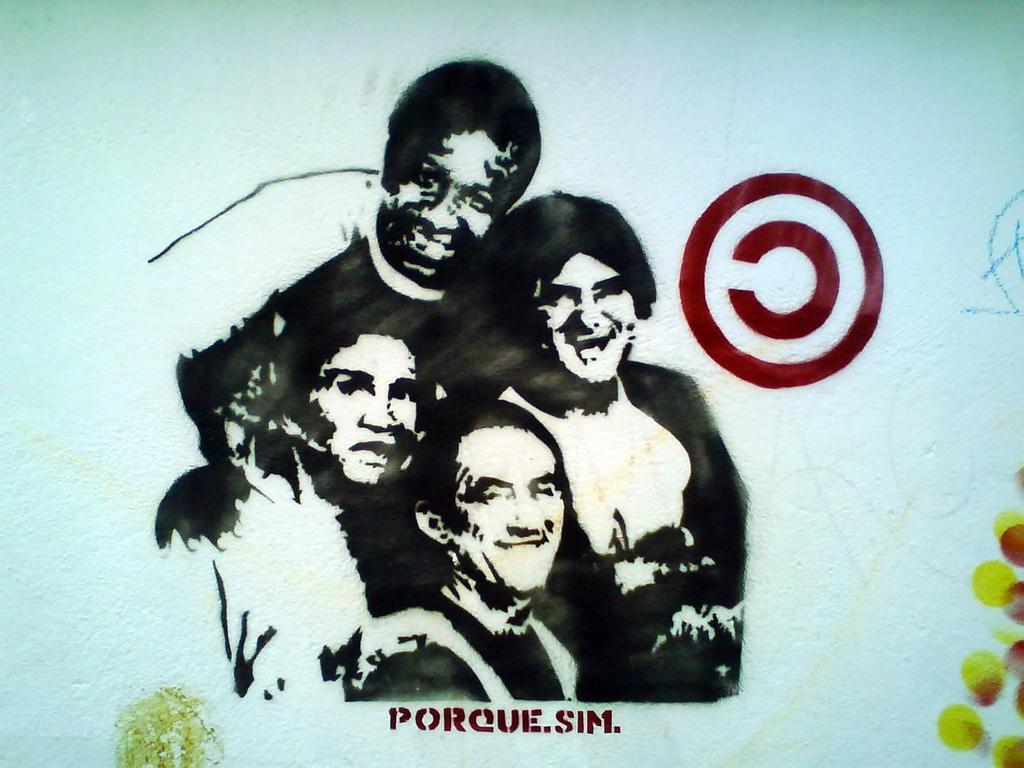How would you summarize this image in a sentence or two? In the center of the image, we can see sketch of some people and in the background, we can see some text written. 